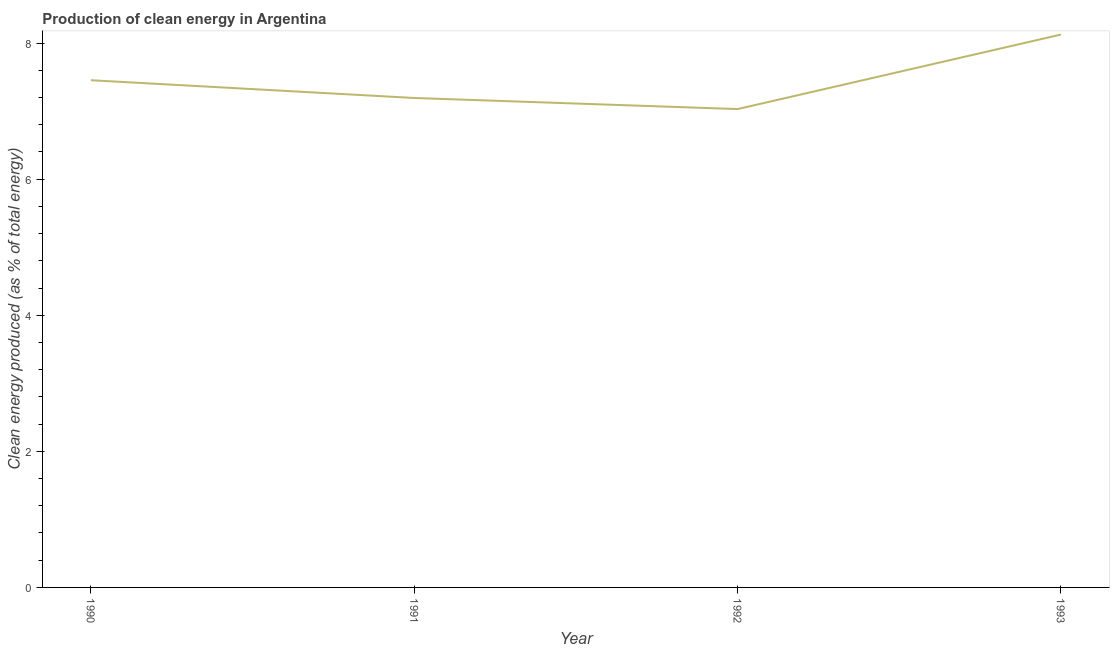What is the production of clean energy in 1990?
Ensure brevity in your answer.  7.46. Across all years, what is the maximum production of clean energy?
Give a very brief answer. 8.13. Across all years, what is the minimum production of clean energy?
Provide a succinct answer. 7.03. In which year was the production of clean energy maximum?
Make the answer very short. 1993. In which year was the production of clean energy minimum?
Provide a short and direct response. 1992. What is the sum of the production of clean energy?
Give a very brief answer. 29.81. What is the difference between the production of clean energy in 1991 and 1992?
Ensure brevity in your answer.  0.16. What is the average production of clean energy per year?
Provide a succinct answer. 7.45. What is the median production of clean energy?
Give a very brief answer. 7.32. In how many years, is the production of clean energy greater than 0.4 %?
Make the answer very short. 4. Do a majority of the years between 1990 and 1992 (inclusive) have production of clean energy greater than 3.2 %?
Keep it short and to the point. Yes. What is the ratio of the production of clean energy in 1991 to that in 1993?
Keep it short and to the point. 0.89. What is the difference between the highest and the second highest production of clean energy?
Offer a terse response. 0.67. Is the sum of the production of clean energy in 1991 and 1993 greater than the maximum production of clean energy across all years?
Keep it short and to the point. Yes. What is the difference between the highest and the lowest production of clean energy?
Provide a succinct answer. 1.1. In how many years, is the production of clean energy greater than the average production of clean energy taken over all years?
Offer a very short reply. 2. Does the production of clean energy monotonically increase over the years?
Your answer should be compact. No. How many years are there in the graph?
Offer a very short reply. 4. What is the difference between two consecutive major ticks on the Y-axis?
Your response must be concise. 2. What is the title of the graph?
Offer a very short reply. Production of clean energy in Argentina. What is the label or title of the X-axis?
Offer a very short reply. Year. What is the label or title of the Y-axis?
Your answer should be compact. Clean energy produced (as % of total energy). What is the Clean energy produced (as % of total energy) of 1990?
Provide a succinct answer. 7.46. What is the Clean energy produced (as % of total energy) in 1991?
Provide a succinct answer. 7.19. What is the Clean energy produced (as % of total energy) of 1992?
Offer a terse response. 7.03. What is the Clean energy produced (as % of total energy) in 1993?
Your answer should be compact. 8.13. What is the difference between the Clean energy produced (as % of total energy) in 1990 and 1991?
Provide a short and direct response. 0.26. What is the difference between the Clean energy produced (as % of total energy) in 1990 and 1992?
Offer a very short reply. 0.42. What is the difference between the Clean energy produced (as % of total energy) in 1990 and 1993?
Keep it short and to the point. -0.67. What is the difference between the Clean energy produced (as % of total energy) in 1991 and 1992?
Your response must be concise. 0.16. What is the difference between the Clean energy produced (as % of total energy) in 1991 and 1993?
Provide a succinct answer. -0.93. What is the difference between the Clean energy produced (as % of total energy) in 1992 and 1993?
Make the answer very short. -1.1. What is the ratio of the Clean energy produced (as % of total energy) in 1990 to that in 1991?
Ensure brevity in your answer.  1.04. What is the ratio of the Clean energy produced (as % of total energy) in 1990 to that in 1992?
Keep it short and to the point. 1.06. What is the ratio of the Clean energy produced (as % of total energy) in 1990 to that in 1993?
Provide a short and direct response. 0.92. What is the ratio of the Clean energy produced (as % of total energy) in 1991 to that in 1992?
Your answer should be very brief. 1.02. What is the ratio of the Clean energy produced (as % of total energy) in 1991 to that in 1993?
Make the answer very short. 0.89. What is the ratio of the Clean energy produced (as % of total energy) in 1992 to that in 1993?
Make the answer very short. 0.86. 